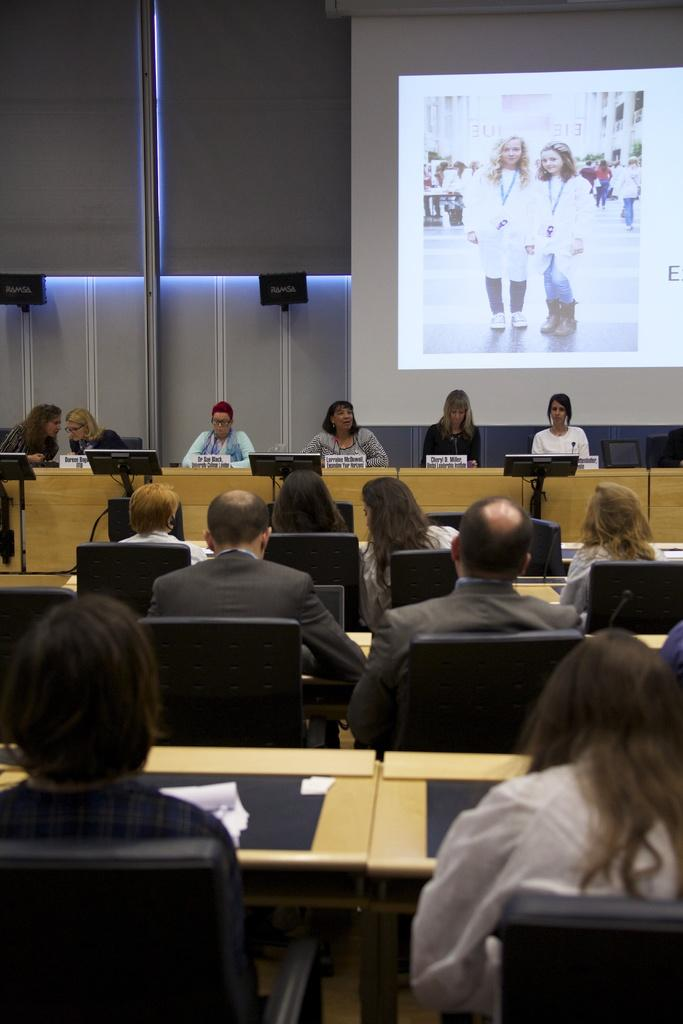What is happening in the image? There is a group of people in the image, and they are sitting on chairs. Can you describe the setting in which the people are sitting? The people are sitting in a location where a projector is visible in the background. What type of beetle can be seen crawling on the projector in the image? There is no beetle present in the image; the projector is visible in the background, but there are no insects or animals mentioned in the facts. 